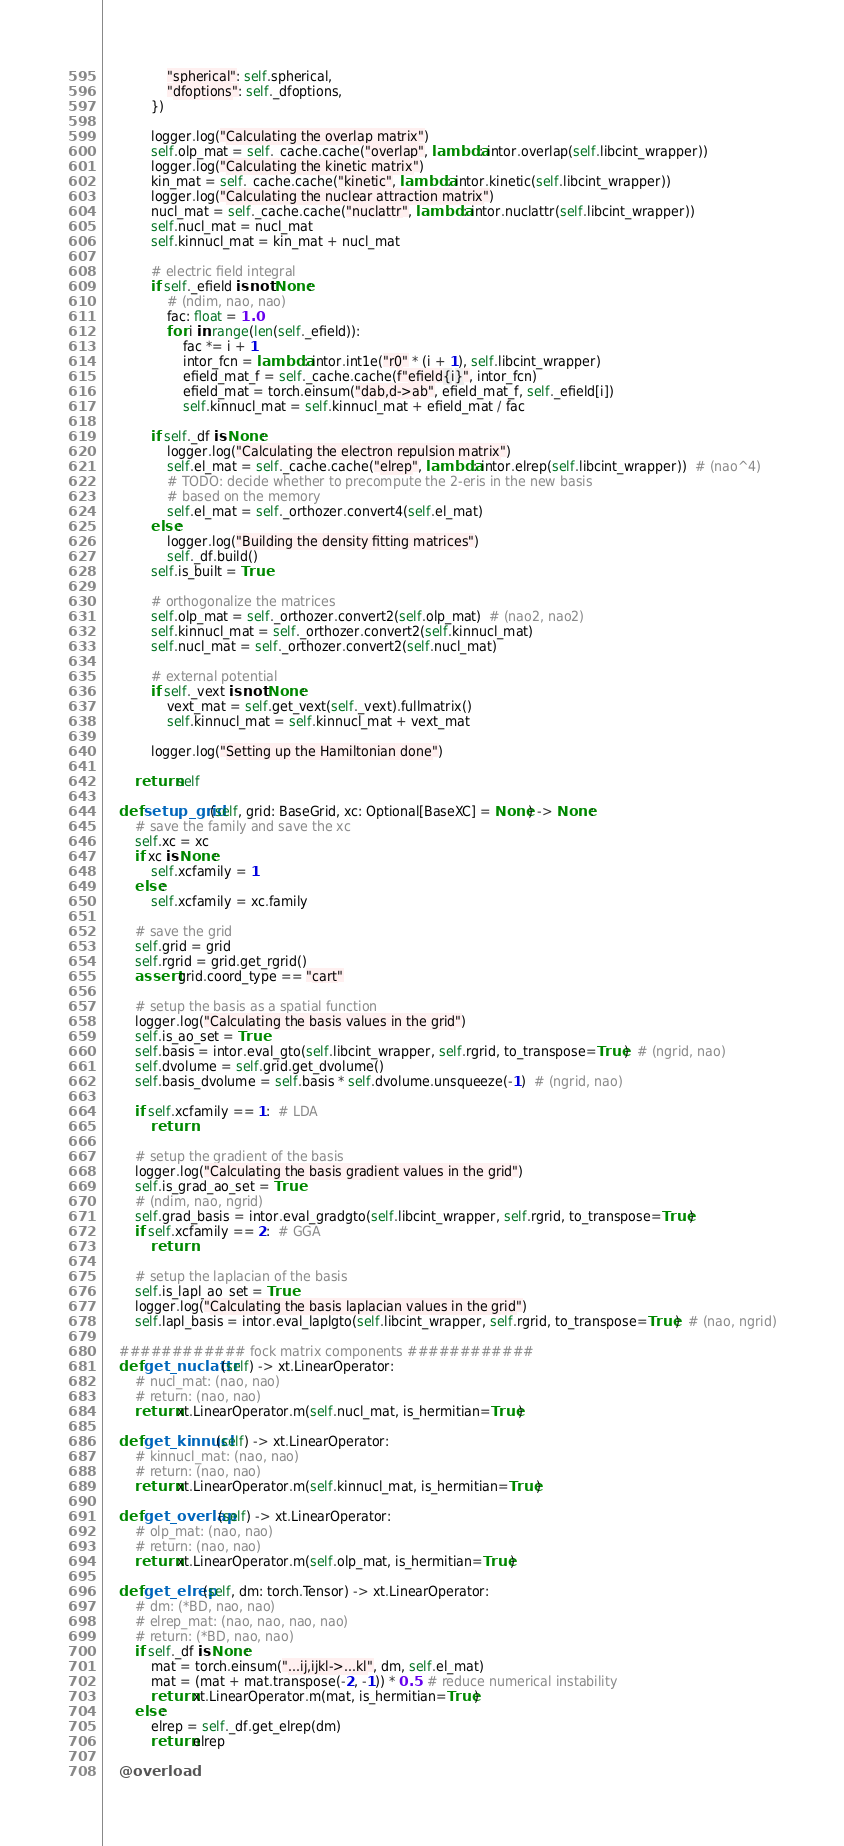<code> <loc_0><loc_0><loc_500><loc_500><_Python_>                "spherical": self.spherical,
                "dfoptions": self._dfoptions,
            })

            logger.log("Calculating the overlap matrix")
            self.olp_mat = self._cache.cache("overlap", lambda: intor.overlap(self.libcint_wrapper))
            logger.log("Calculating the kinetic matrix")
            kin_mat = self._cache.cache("kinetic", lambda: intor.kinetic(self.libcint_wrapper))
            logger.log("Calculating the nuclear attraction matrix")
            nucl_mat = self._cache.cache("nuclattr", lambda: intor.nuclattr(self.libcint_wrapper))
            self.nucl_mat = nucl_mat
            self.kinnucl_mat = kin_mat + nucl_mat

            # electric field integral
            if self._efield is not None:
                # (ndim, nao, nao)
                fac: float = 1.0
                for i in range(len(self._efield)):
                    fac *= i + 1
                    intor_fcn = lambda: intor.int1e("r0" * (i + 1), self.libcint_wrapper)
                    efield_mat_f = self._cache.cache(f"efield{i}", intor_fcn)
                    efield_mat = torch.einsum("dab,d->ab", efield_mat_f, self._efield[i])
                    self.kinnucl_mat = self.kinnucl_mat + efield_mat / fac

            if self._df is None:
                logger.log("Calculating the electron repulsion matrix")
                self.el_mat = self._cache.cache("elrep", lambda: intor.elrep(self.libcint_wrapper))  # (nao^4)
                # TODO: decide whether to precompute the 2-eris in the new basis
                # based on the memory
                self.el_mat = self._orthozer.convert4(self.el_mat)
            else:
                logger.log("Building the density fitting matrices")
                self._df.build()
            self.is_built = True

            # orthogonalize the matrices
            self.olp_mat = self._orthozer.convert2(self.olp_mat)  # (nao2, nao2)
            self.kinnucl_mat = self._orthozer.convert2(self.kinnucl_mat)
            self.nucl_mat = self._orthozer.convert2(self.nucl_mat)

            # external potential
            if self._vext is not None:
                vext_mat = self.get_vext(self._vext).fullmatrix()
                self.kinnucl_mat = self.kinnucl_mat + vext_mat

            logger.log("Setting up the Hamiltonian done")

        return self

    def setup_grid(self, grid: BaseGrid, xc: Optional[BaseXC] = None) -> None:
        # save the family and save the xc
        self.xc = xc
        if xc is None:
            self.xcfamily = 1
        else:
            self.xcfamily = xc.family

        # save the grid
        self.grid = grid
        self.rgrid = grid.get_rgrid()
        assert grid.coord_type == "cart"

        # setup the basis as a spatial function
        logger.log("Calculating the basis values in the grid")
        self.is_ao_set = True
        self.basis = intor.eval_gto(self.libcint_wrapper, self.rgrid, to_transpose=True)  # (ngrid, nao)
        self.dvolume = self.grid.get_dvolume()
        self.basis_dvolume = self.basis * self.dvolume.unsqueeze(-1)  # (ngrid, nao)

        if self.xcfamily == 1:  # LDA
            return

        # setup the gradient of the basis
        logger.log("Calculating the basis gradient values in the grid")
        self.is_grad_ao_set = True
        # (ndim, nao, ngrid)
        self.grad_basis = intor.eval_gradgto(self.libcint_wrapper, self.rgrid, to_transpose=True)
        if self.xcfamily == 2:  # GGA
            return

        # setup the laplacian of the basis
        self.is_lapl_ao_set = True
        logger.log("Calculating the basis laplacian values in the grid")
        self.lapl_basis = intor.eval_laplgto(self.libcint_wrapper, self.rgrid, to_transpose=True)  # (nao, ngrid)

    ############ fock matrix components ############
    def get_nuclattr(self) -> xt.LinearOperator:
        # nucl_mat: (nao, nao)
        # return: (nao, nao)
        return xt.LinearOperator.m(self.nucl_mat, is_hermitian=True)

    def get_kinnucl(self) -> xt.LinearOperator:
        # kinnucl_mat: (nao, nao)
        # return: (nao, nao)
        return xt.LinearOperator.m(self.kinnucl_mat, is_hermitian=True)

    def get_overlap(self) -> xt.LinearOperator:
        # olp_mat: (nao, nao)
        # return: (nao, nao)
        return xt.LinearOperator.m(self.olp_mat, is_hermitian=True)

    def get_elrep(self, dm: torch.Tensor) -> xt.LinearOperator:
        # dm: (*BD, nao, nao)
        # elrep_mat: (nao, nao, nao, nao)
        # return: (*BD, nao, nao)
        if self._df is None:
            mat = torch.einsum("...ij,ijkl->...kl", dm, self.el_mat)
            mat = (mat + mat.transpose(-2, -1)) * 0.5  # reduce numerical instability
            return xt.LinearOperator.m(mat, is_hermitian=True)
        else:
            elrep = self._df.get_elrep(dm)
            return elrep

    @overload</code> 